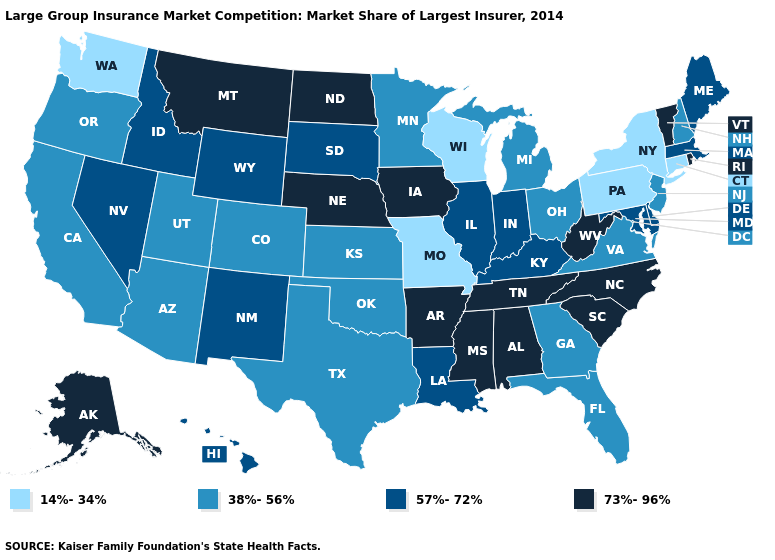How many symbols are there in the legend?
Short answer required. 4. What is the highest value in the USA?
Keep it brief. 73%-96%. What is the value of Nebraska?
Keep it brief. 73%-96%. What is the lowest value in states that border Utah?
Give a very brief answer. 38%-56%. What is the value of Minnesota?
Be succinct. 38%-56%. What is the value of Arkansas?
Be succinct. 73%-96%. What is the highest value in the USA?
Keep it brief. 73%-96%. Does Indiana have a higher value than Louisiana?
Write a very short answer. No. What is the value of Rhode Island?
Short answer required. 73%-96%. What is the highest value in the West ?
Concise answer only. 73%-96%. What is the lowest value in the Northeast?
Concise answer only. 14%-34%. Which states hav the highest value in the MidWest?
Write a very short answer. Iowa, Nebraska, North Dakota. Name the states that have a value in the range 14%-34%?
Give a very brief answer. Connecticut, Missouri, New York, Pennsylvania, Washington, Wisconsin. Name the states that have a value in the range 14%-34%?
Concise answer only. Connecticut, Missouri, New York, Pennsylvania, Washington, Wisconsin. What is the highest value in the Northeast ?
Be succinct. 73%-96%. 